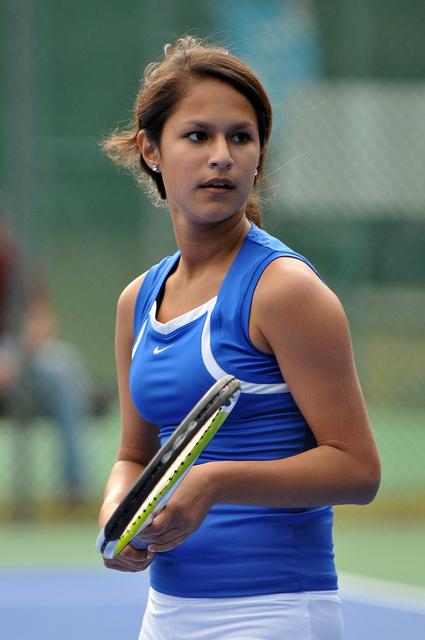What is she doing?
Give a very brief answer. Playing tennis. What sport is she going to play?
Give a very brief answer. Tennis. What color is the girl's shirt?
Give a very brief answer. Blue. 